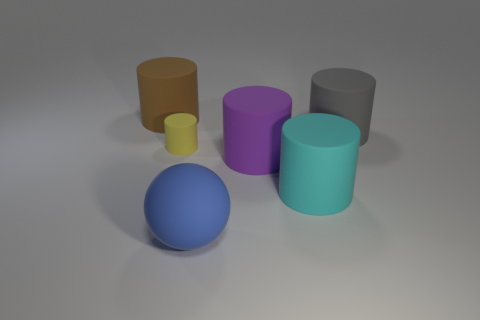Which object appears to be the smallest, and what could its size relative to the others indicate about its position or function? The yellow cylinder appears to be the smallest object. Its size could indicate that it's positioned closer to the viewer than the others or that it is a smaller version of the other objects, potentially serving a distinct purpose or representing a different category in a grouping. 